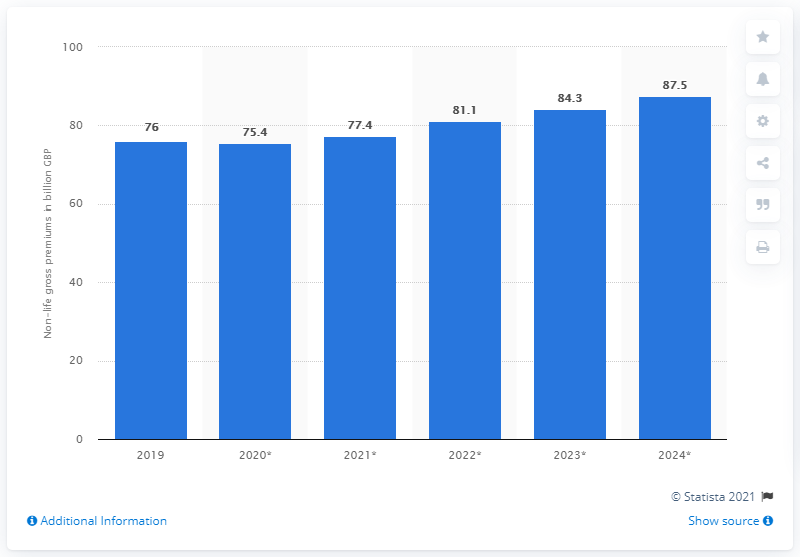Indicate a few pertinent items in this graphic. The estimated value of non-life insurance gross premiums in the UK by 2024 is expected to be 87.5.. In 2019, the gross premium of non-life insurance was 75.4. 